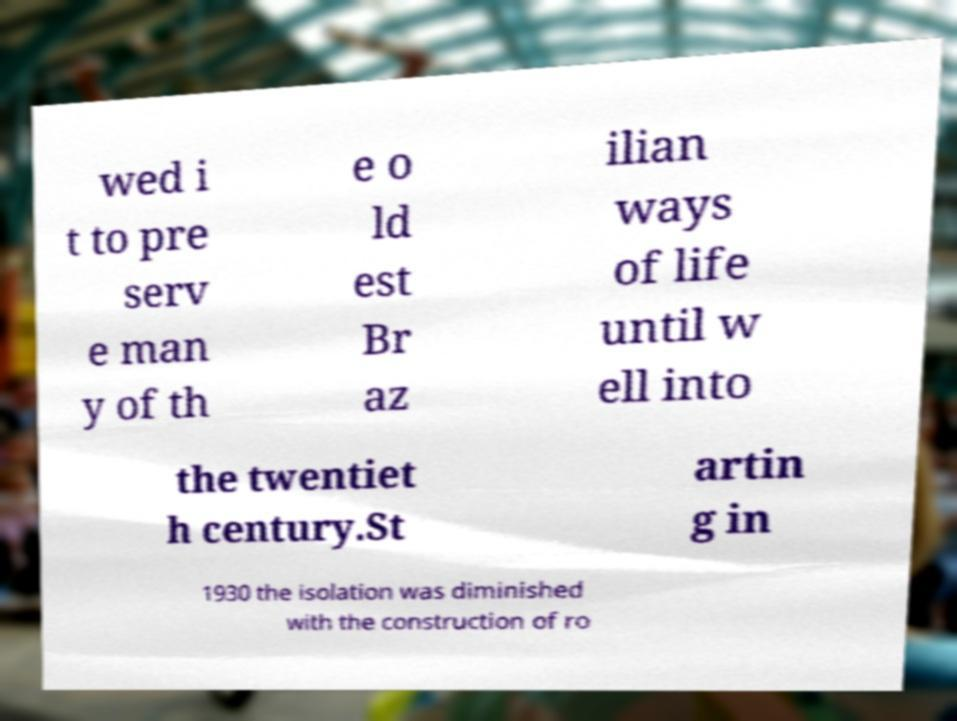There's text embedded in this image that I need extracted. Can you transcribe it verbatim? wed i t to pre serv e man y of th e o ld est Br az ilian ways of life until w ell into the twentiet h century.St artin g in 1930 the isolation was diminished with the construction of ro 